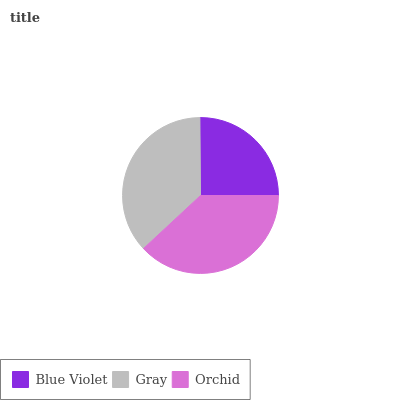Is Blue Violet the minimum?
Answer yes or no. Yes. Is Orchid the maximum?
Answer yes or no. Yes. Is Gray the minimum?
Answer yes or no. No. Is Gray the maximum?
Answer yes or no. No. Is Gray greater than Blue Violet?
Answer yes or no. Yes. Is Blue Violet less than Gray?
Answer yes or no. Yes. Is Blue Violet greater than Gray?
Answer yes or no. No. Is Gray less than Blue Violet?
Answer yes or no. No. Is Gray the high median?
Answer yes or no. Yes. Is Gray the low median?
Answer yes or no. Yes. Is Blue Violet the high median?
Answer yes or no. No. Is Orchid the low median?
Answer yes or no. No. 